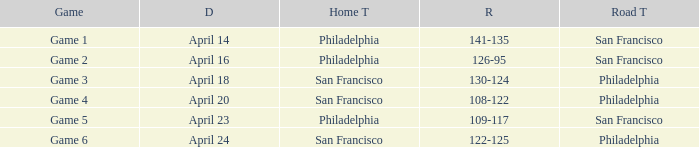Which game had Philadelphia as its home team and was played on April 23? Game 5. 